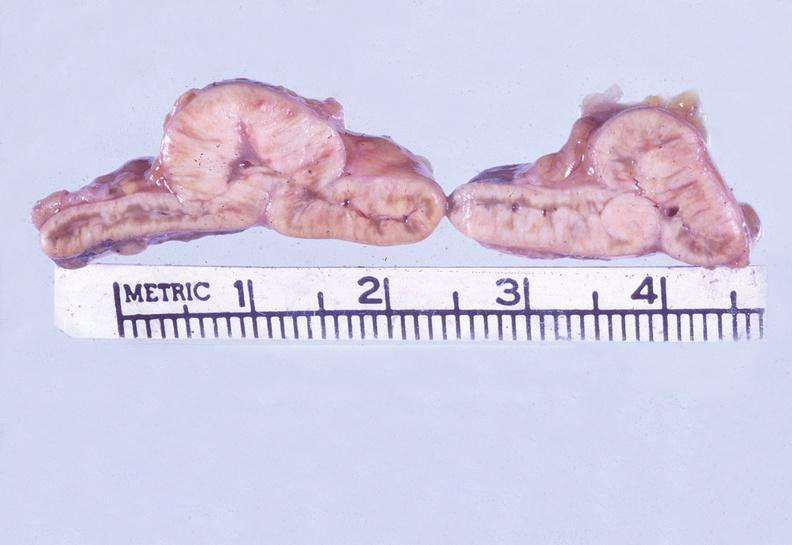what does this image show?
Answer the question using a single word or phrase. Adrenal 